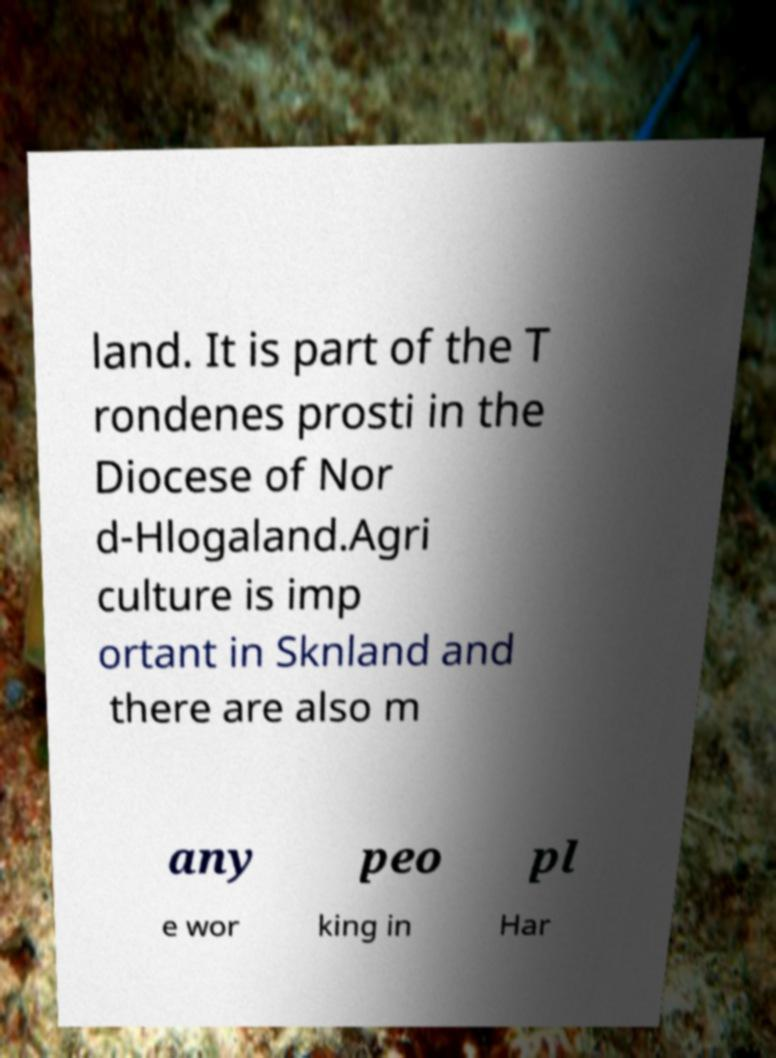For documentation purposes, I need the text within this image transcribed. Could you provide that? land. It is part of the T rondenes prosti in the Diocese of Nor d-Hlogaland.Agri culture is imp ortant in Sknland and there are also m any peo pl e wor king in Har 